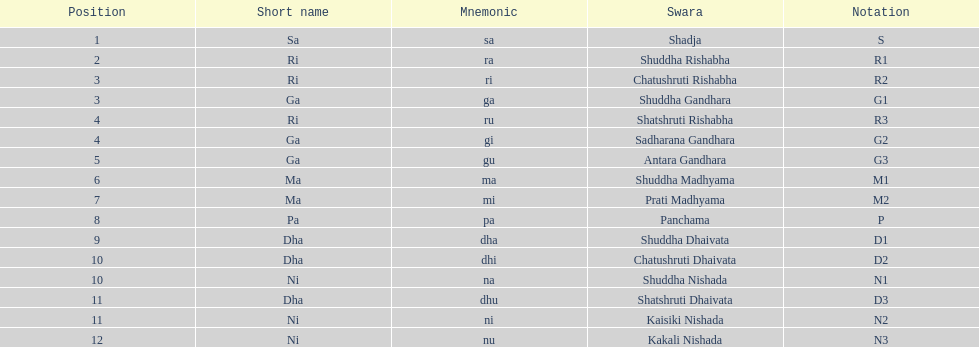On average how many of the swara have a short name that begin with d or g? 6. Would you be able to parse every entry in this table? {'header': ['Position', 'Short name', 'Mnemonic', 'Swara', 'Notation'], 'rows': [['1', 'Sa', 'sa', 'Shadja', 'S'], ['2', 'Ri', 'ra', 'Shuddha Rishabha', 'R1'], ['3', 'Ri', 'ri', 'Chatushruti Rishabha', 'R2'], ['3', 'Ga', 'ga', 'Shuddha Gandhara', 'G1'], ['4', 'Ri', 'ru', 'Shatshruti Rishabha', 'R3'], ['4', 'Ga', 'gi', 'Sadharana Gandhara', 'G2'], ['5', 'Ga', 'gu', 'Antara Gandhara', 'G3'], ['6', 'Ma', 'ma', 'Shuddha Madhyama', 'M1'], ['7', 'Ma', 'mi', 'Prati Madhyama', 'M2'], ['8', 'Pa', 'pa', 'Panchama', 'P'], ['9', 'Dha', 'dha', 'Shuddha Dhaivata', 'D1'], ['10', 'Dha', 'dhi', 'Chatushruti Dhaivata', 'D2'], ['10', 'Ni', 'na', 'Shuddha Nishada', 'N1'], ['11', 'Dha', 'dhu', 'Shatshruti Dhaivata', 'D3'], ['11', 'Ni', 'ni', 'Kaisiki Nishada', 'N2'], ['12', 'Ni', 'nu', 'Kakali Nishada', 'N3']]} 